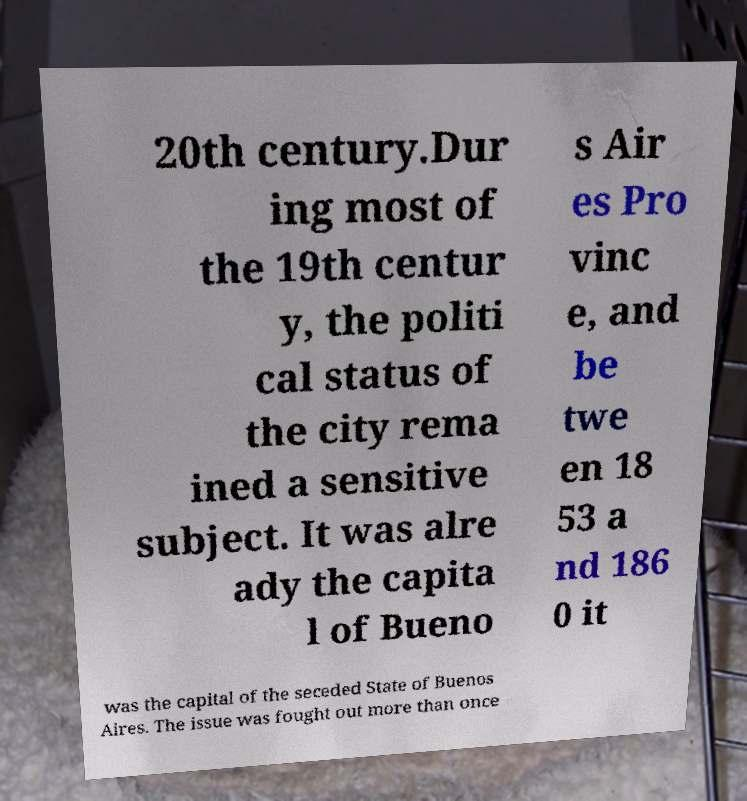Can you read and provide the text displayed in the image?This photo seems to have some interesting text. Can you extract and type it out for me? 20th century.Dur ing most of the 19th centur y, the politi cal status of the city rema ined a sensitive subject. It was alre ady the capita l of Bueno s Air es Pro vinc e, and be twe en 18 53 a nd 186 0 it was the capital of the seceded State of Buenos Aires. The issue was fought out more than once 